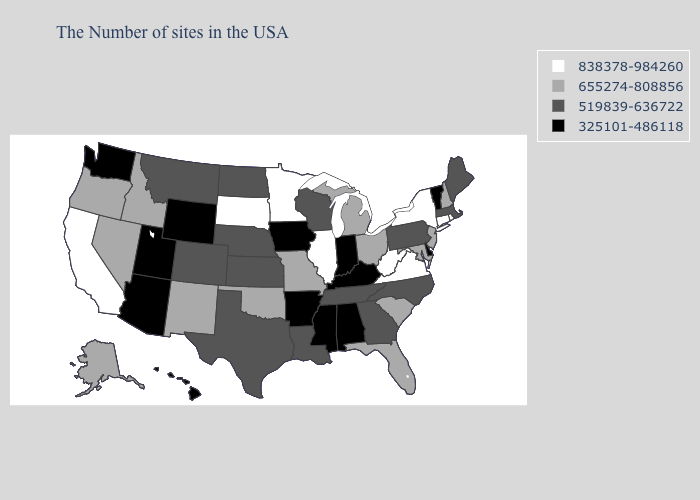What is the value of Louisiana?
Write a very short answer. 519839-636722. What is the lowest value in states that border Massachusetts?
Give a very brief answer. 325101-486118. Does Washington have the highest value in the USA?
Write a very short answer. No. Does the map have missing data?
Short answer required. No. Does Mississippi have the lowest value in the USA?
Quick response, please. Yes. What is the value of Massachusetts?
Be succinct. 519839-636722. What is the value of Oklahoma?
Answer briefly. 655274-808856. Name the states that have a value in the range 325101-486118?
Be succinct. Vermont, Delaware, Kentucky, Indiana, Alabama, Mississippi, Arkansas, Iowa, Wyoming, Utah, Arizona, Washington, Hawaii. Name the states that have a value in the range 655274-808856?
Be succinct. New Hampshire, New Jersey, Maryland, South Carolina, Ohio, Florida, Michigan, Missouri, Oklahoma, New Mexico, Idaho, Nevada, Oregon, Alaska. Among the states that border Nevada , does California have the highest value?
Write a very short answer. Yes. Name the states that have a value in the range 519839-636722?
Answer briefly. Maine, Massachusetts, Pennsylvania, North Carolina, Georgia, Tennessee, Wisconsin, Louisiana, Kansas, Nebraska, Texas, North Dakota, Colorado, Montana. What is the value of Virginia?
Be succinct. 838378-984260. Does Iowa have the lowest value in the MidWest?
Quick response, please. Yes. What is the lowest value in states that border Oklahoma?
Quick response, please. 325101-486118. Does Idaho have the highest value in the West?
Give a very brief answer. No. 